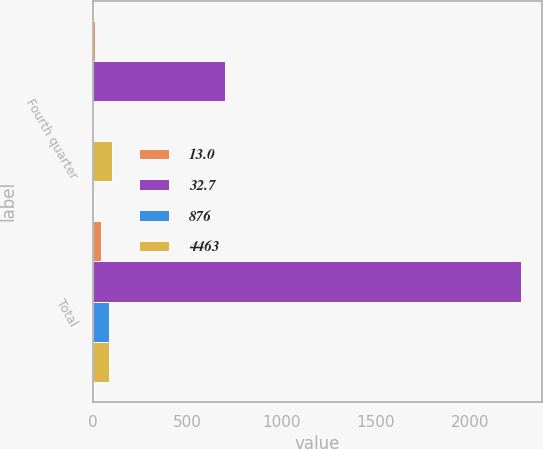<chart> <loc_0><loc_0><loc_500><loc_500><stacked_bar_chart><ecel><fcel>Fourth quarter<fcel>Total<nl><fcel>13<fcel>12.6<fcel>45.3<nl><fcel>32.7<fcel>700<fcel>2268<nl><fcel>876<fcel>1.8<fcel>87<nl><fcel>4463<fcel>100<fcel>87<nl></chart> 